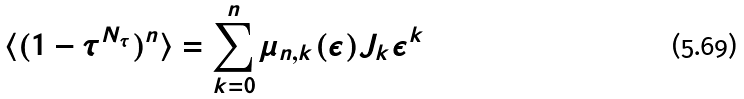Convert formula to latex. <formula><loc_0><loc_0><loc_500><loc_500>\langle ( 1 - \tau ^ { N _ { \tau } } ) ^ { n } \rangle = \sum _ { k = 0 } ^ { n } \mu _ { n , k } ( \epsilon ) J _ { k } \epsilon ^ { k }</formula> 